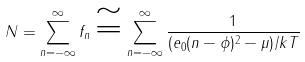<formula> <loc_0><loc_0><loc_500><loc_500>N = \sum _ { n = - \infty } ^ { \infty } f _ { n } \cong \sum _ { n = - \infty } ^ { \infty } \frac { 1 } { ( e _ { 0 } ( n - \phi ) ^ { 2 } - \mu ) / k T }</formula> 